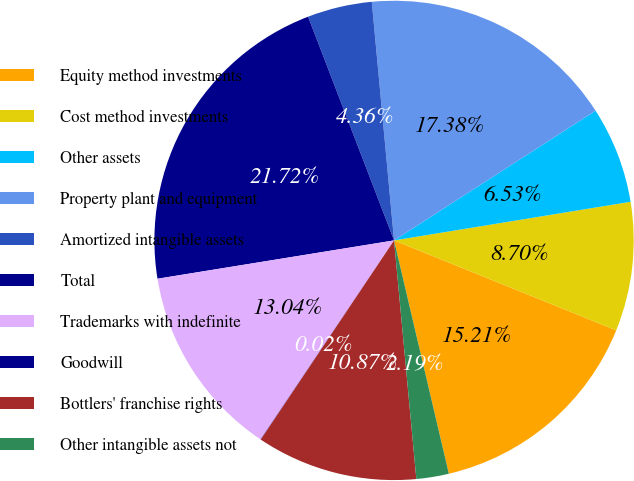Convert chart to OTSL. <chart><loc_0><loc_0><loc_500><loc_500><pie_chart><fcel>Equity method investments<fcel>Cost method investments<fcel>Other assets<fcel>Property plant and equipment<fcel>Amortized intangible assets<fcel>Total<fcel>Trademarks with indefinite<fcel>Goodwill<fcel>Bottlers' franchise rights<fcel>Other intangible assets not<nl><fcel>15.21%<fcel>8.7%<fcel>6.53%<fcel>17.38%<fcel>4.36%<fcel>21.72%<fcel>13.04%<fcel>0.02%<fcel>10.87%<fcel>2.19%<nl></chart> 